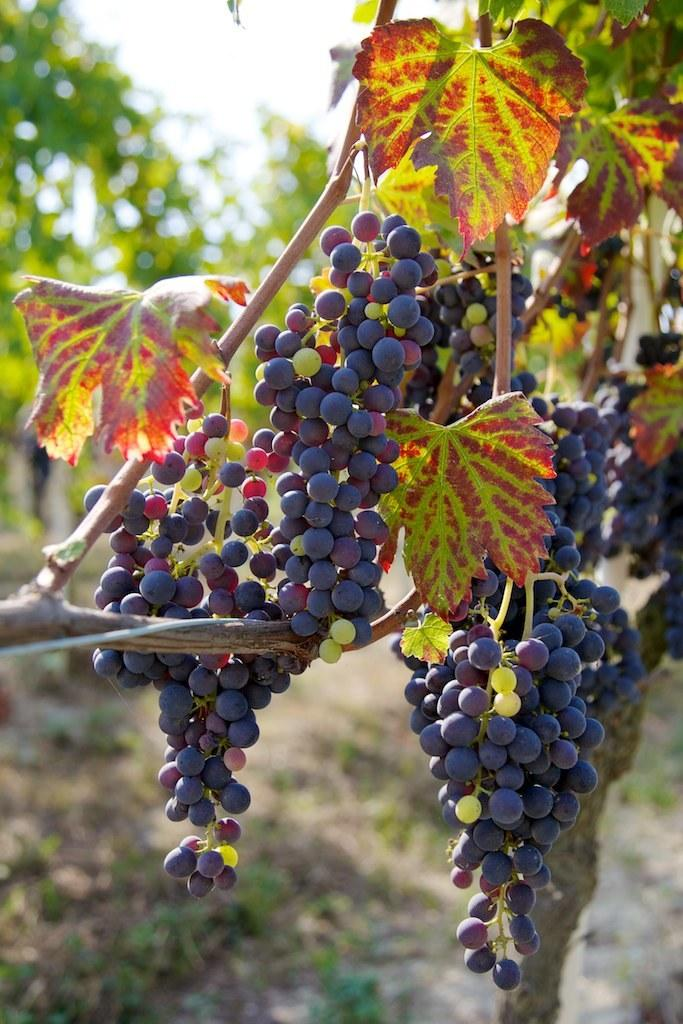What type of fruit can be seen on a tree in the image? There is a bunch of grapes on a tree in the image. What else can be seen in the background of the image? There are trees visible in the background of the image. What part of the natural environment is visible in the image? The sky is visible in the image. What type of ink is being used by the committee in the image? There is no committee or ink present in the image; it features a bunch of grapes on a tree and trees in the background. What type of field is visible in the image? There is no field visible in the image; it features a bunch of grapes on a tree and trees in the background. 